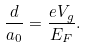Convert formula to latex. <formula><loc_0><loc_0><loc_500><loc_500>\frac { d } { a _ { 0 } } = \frac { e V _ { g } } { E _ { F } } .</formula> 